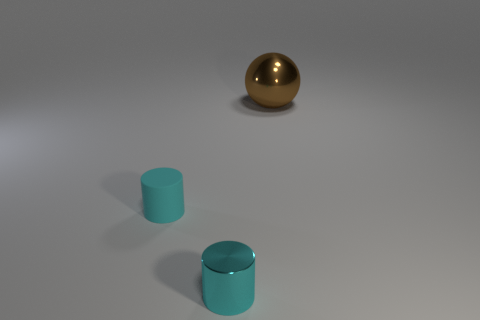Are there any other things that are the same shape as the brown object?
Offer a terse response. No. Does the matte object have the same shape as the small shiny thing?
Your answer should be very brief. Yes. What is the size of the cyan thing to the left of the tiny cyan thing on the right side of the matte object?
Ensure brevity in your answer.  Small. Are there any metallic balls that have the same size as the cyan rubber object?
Make the answer very short. No. There is a metal thing to the left of the large brown metal ball; is it the same size as the cylinder to the left of the small cyan metallic cylinder?
Your response must be concise. Yes. There is a small object behind the metal object that is on the left side of the brown ball; what shape is it?
Provide a succinct answer. Cylinder. What number of cyan metallic cylinders are in front of the small shiny thing?
Give a very brief answer. 0. What is the color of the thing that is made of the same material as the large ball?
Offer a very short reply. Cyan. Is the size of the sphere the same as the shiny object in front of the tiny cyan matte cylinder?
Provide a short and direct response. No. There is a cyan object that is in front of the tiny cyan cylinder on the left side of the cyan cylinder that is in front of the tiny matte cylinder; what is its size?
Offer a very short reply. Small. 